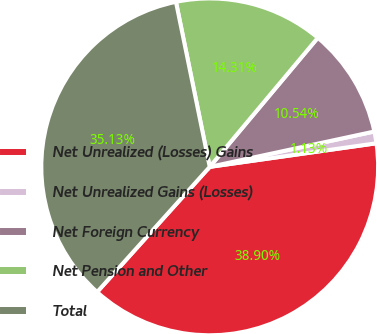Convert chart. <chart><loc_0><loc_0><loc_500><loc_500><pie_chart><fcel>Net Unrealized (Losses) Gains<fcel>Net Unrealized Gains (Losses)<fcel>Net Foreign Currency<fcel>Net Pension and Other<fcel>Total<nl><fcel>38.9%<fcel>1.13%<fcel>10.54%<fcel>14.31%<fcel>35.13%<nl></chart> 